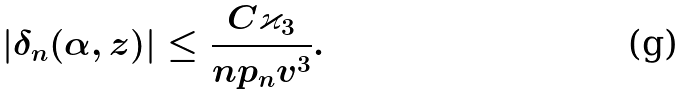Convert formula to latex. <formula><loc_0><loc_0><loc_500><loc_500>| \delta _ { n } ( \alpha , z ) | \leq \frac { C \varkappa _ { 3 } } { n p _ { n } v ^ { 3 } } .</formula> 